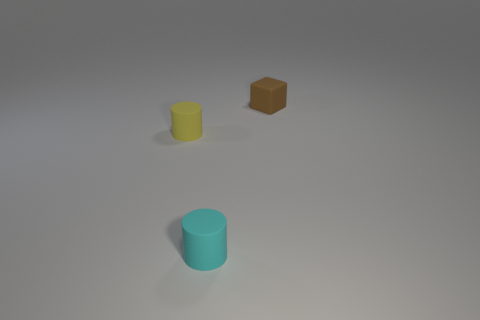Subtract 1 cylinders. How many cylinders are left? 1 Add 1 blue metal cubes. How many blue metal cubes exist? 1 Add 2 small brown matte cubes. How many objects exist? 5 Subtract 0 green cylinders. How many objects are left? 3 Subtract all cylinders. How many objects are left? 1 Subtract all brown cylinders. Subtract all gray cubes. How many cylinders are left? 2 Subtract all purple spheres. How many cyan cylinders are left? 1 Subtract all small cylinders. Subtract all tiny brown blocks. How many objects are left? 0 Add 2 tiny cyan cylinders. How many tiny cyan cylinders are left? 3 